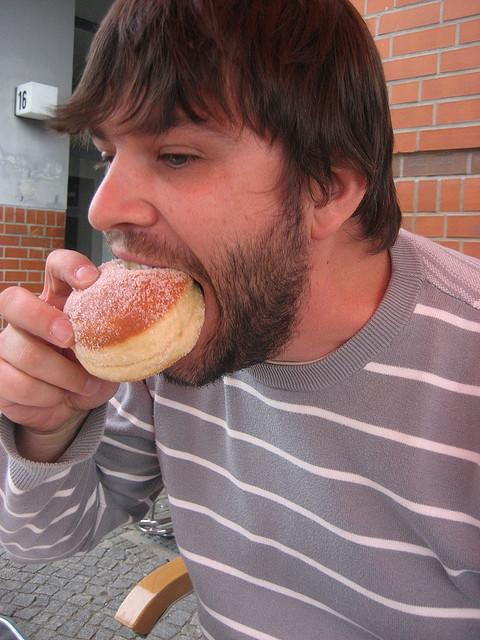Which character wears a shirt with a similar pattern to this man's shirt? waldo 